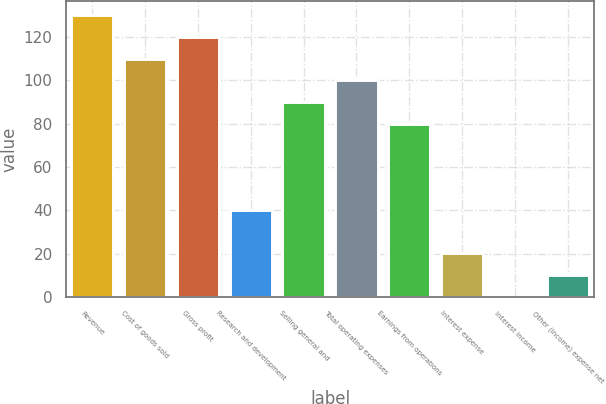<chart> <loc_0><loc_0><loc_500><loc_500><bar_chart><fcel>Revenue<fcel>Cost of goods sold<fcel>Gross profit<fcel>Research and development<fcel>Selling general and<fcel>Total operating expenses<fcel>Earnings from operations<fcel>Interest expense<fcel>Interest income<fcel>Other (income) expense net<nl><fcel>129.97<fcel>109.99<fcel>119.98<fcel>40.06<fcel>90.01<fcel>100<fcel>80.02<fcel>20.08<fcel>0.1<fcel>10.09<nl></chart> 